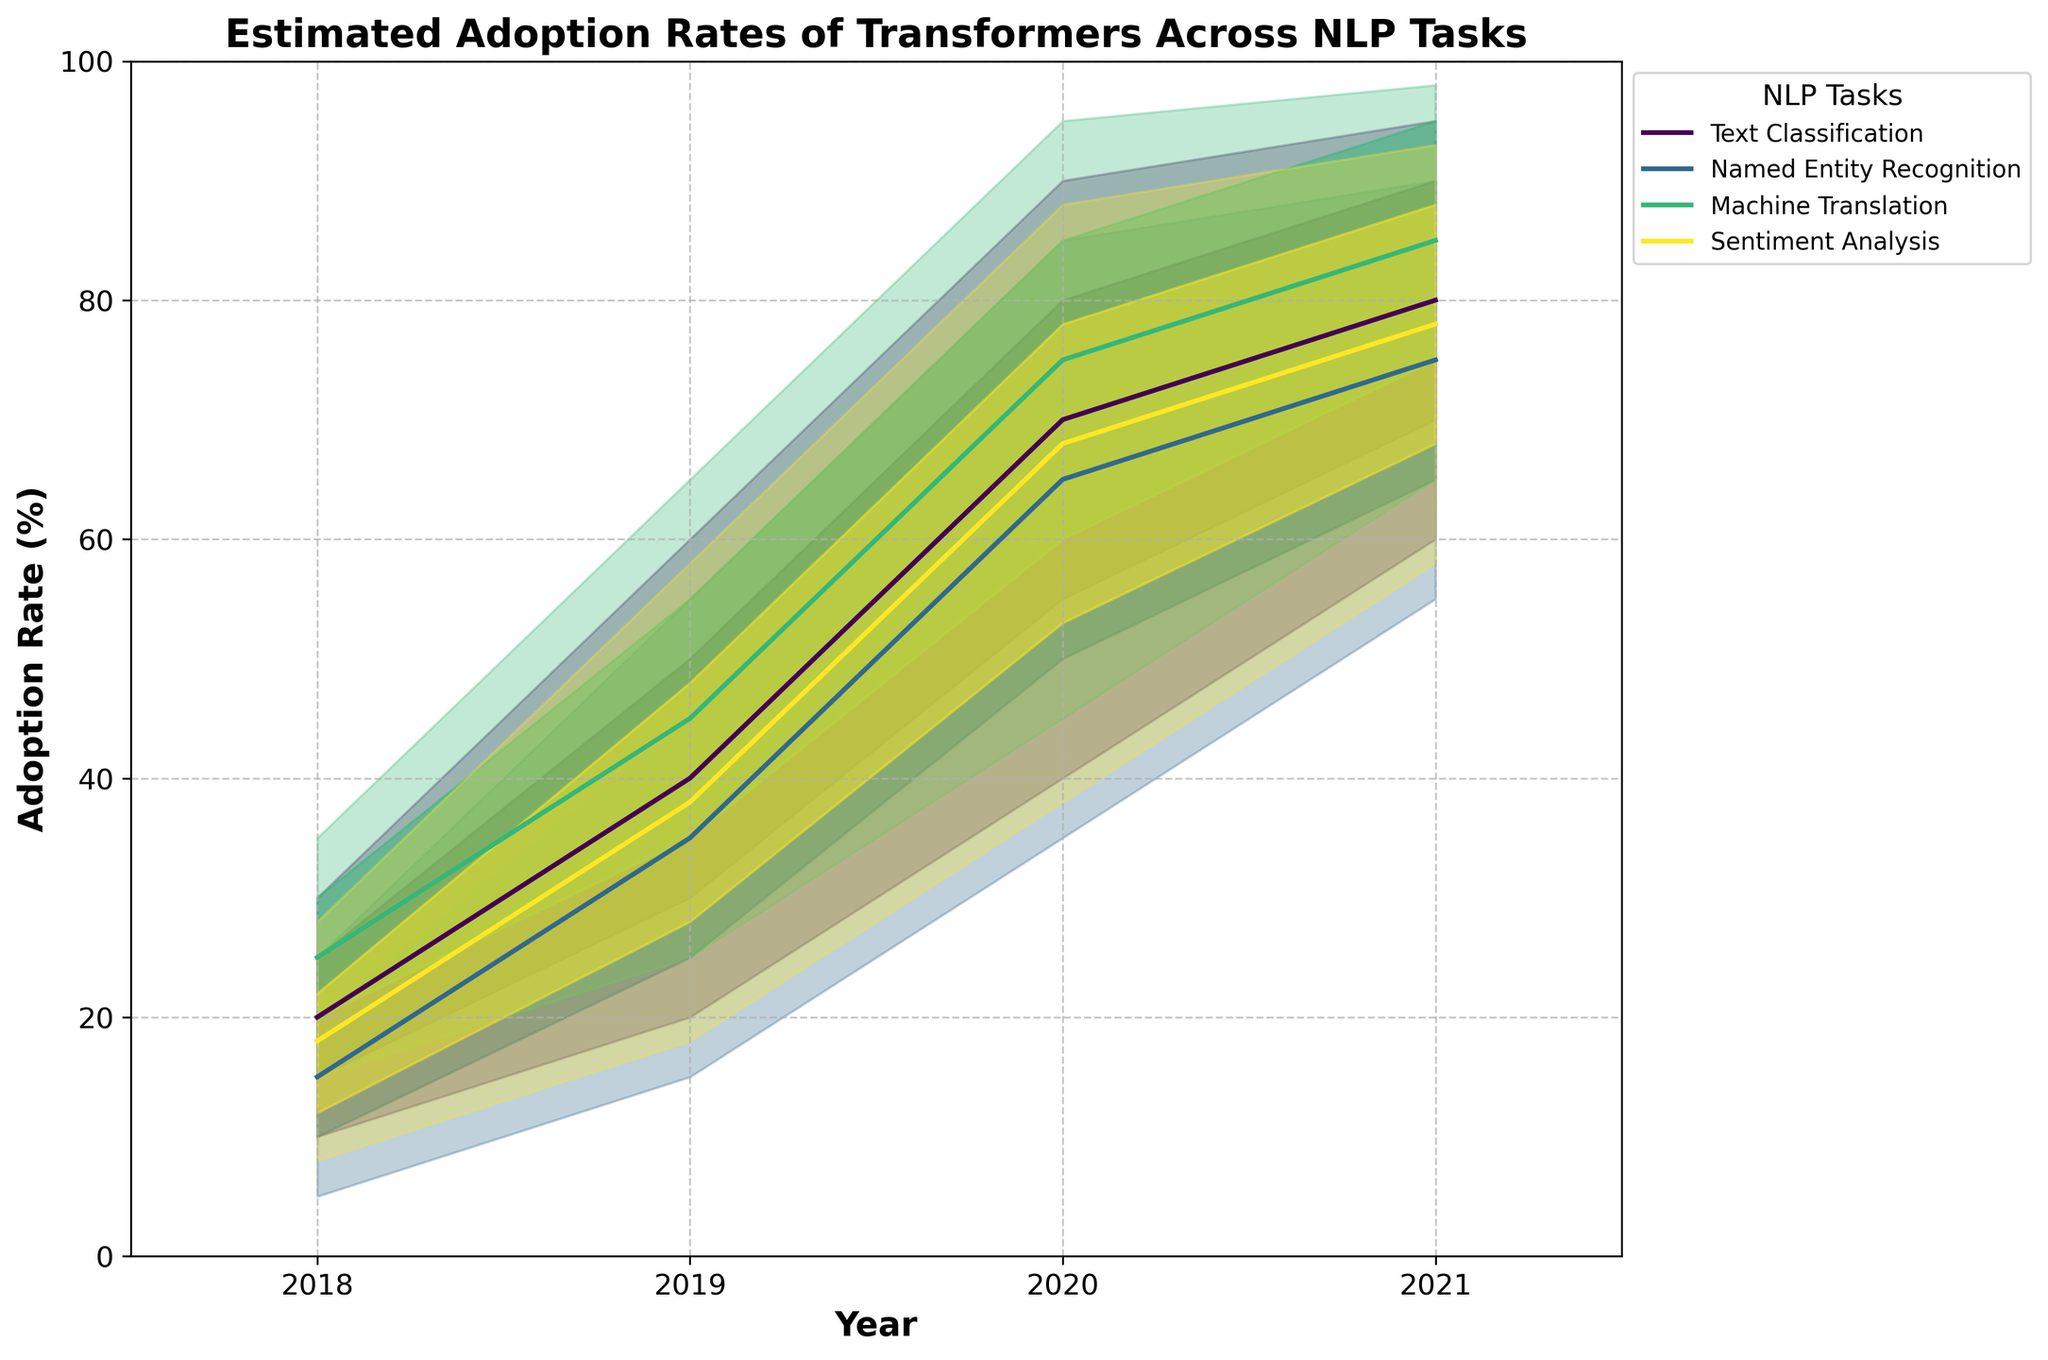How many NLP tasks are represented in the figure? By looking at the legend in the figure, we can see the number of different colors, each representing a different NLP task.
Answer: 4 What is the title of the figure? The title of the figure is located at the top of the plot and is generally in a larger and bolder font.
Answer: Estimated Adoption Rates of Transformers Across NLP Tasks In 2020, what is the high-end adoption rate for Machine Translation? Find the 2020 marker on the x-axis and then look at the highest shaded area for Machine Translation (typically the top line for the color representing Machine Translation). The high-end adoption rate is the uppermost value.
Answer: 95% Which NLP task had the highest estimated adoption rate in 2021? Look at the 2021 markers on the x-axis and find the uppermost line among different colors; the task corresponding to this line is the one with the highest estimated adoption rate.
Answer: Machine Translation How did the adoption rate for Named Entity Recognition change from 2018 to 2021 at the median level? Identify the mid-point marker for Named Entity Recognition each year from 2018 to 2021 and note the changes: In 2018 it starts at 15%, and by 2021, it reaches 75%.
Answer: Increased from 15% to 75% What is the range of estimated adoption rates for Text Classification in 2019? Look at the 2019 marker on the x-axis, and find the upper and lower limits of the shaded area for Text Classification. Calculate the range by subtracting the lower value from the higher value (60% - 20%).
Answer: 40% Compare the mid adoption rates of Sentiment Analysis and Named Entity Recognition for the year 2020 Find the 2020 marker on the x-axis and check the mid-point lines for Sentiment Analysis and Named Entity Recognition. The mid-point of Sentiment Analysis in 2020 is 68%, and for Named Entity Recognition, it is 65%.
Answer: Sentiment Analysis is higher by 3% What can we infer about the trend of transformer adoption in Text Classification from 2018 to 2021? Observe the trend line in the median of Text Classification from 2018 to 2021. Note the increment in the line each year. The trend shows a consistent upward increase from 20% in 2018 to 80% in 2021.
Answer: Increasing trend What years does the x-axis cover in the figure? Look at the x-axis labels to identify the range of years covered in the figure.
Answer: 2018 to 2021 Which NLP task had the narrowest adoption range in 2021? Compare the width of the shaded areas in 2021 across different tasks; the narrower the shaded area, the more consistent the estimates. Text Classification has the smallest range between 60% and 95% in 2021.
Answer: Text Classification 